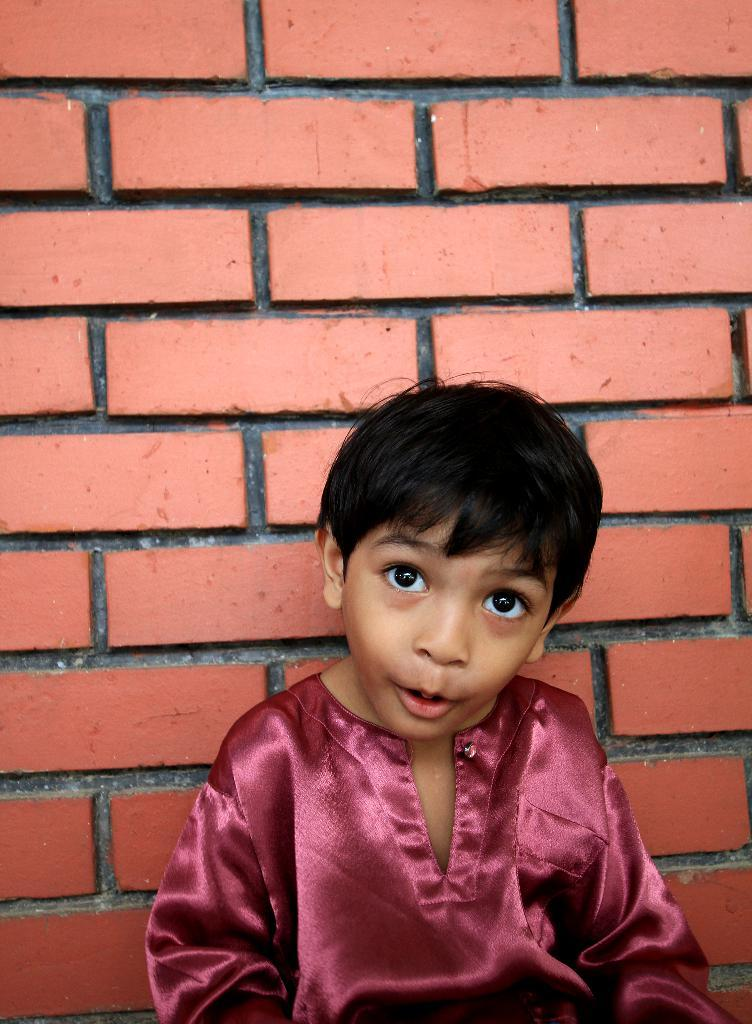Who is the main subject in the image? There is a boy in the image. Where is the boy located in relation to other objects or structures? The boy is in front of a wall. What type of shade does the boy provide in the image? The boy does not provide any shade in the image, as there is no mention of shade or any object that could cast a shadow. 